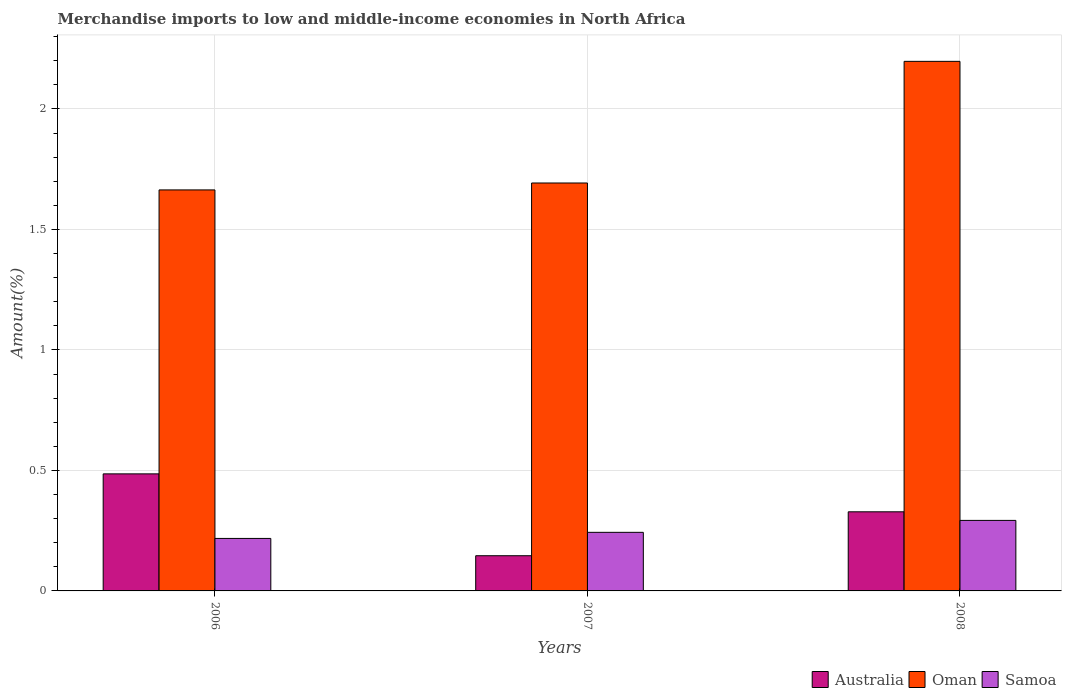Are the number of bars per tick equal to the number of legend labels?
Provide a succinct answer. Yes. How many bars are there on the 1st tick from the right?
Give a very brief answer. 3. In how many cases, is the number of bars for a given year not equal to the number of legend labels?
Your response must be concise. 0. What is the percentage of amount earned from merchandise imports in Samoa in 2007?
Your answer should be compact. 0.24. Across all years, what is the maximum percentage of amount earned from merchandise imports in Samoa?
Your response must be concise. 0.29. Across all years, what is the minimum percentage of amount earned from merchandise imports in Australia?
Ensure brevity in your answer.  0.15. What is the total percentage of amount earned from merchandise imports in Oman in the graph?
Keep it short and to the point. 5.55. What is the difference between the percentage of amount earned from merchandise imports in Samoa in 2007 and that in 2008?
Give a very brief answer. -0.05. What is the difference between the percentage of amount earned from merchandise imports in Oman in 2008 and the percentage of amount earned from merchandise imports in Australia in 2006?
Your response must be concise. 1.71. What is the average percentage of amount earned from merchandise imports in Samoa per year?
Your answer should be compact. 0.25. In the year 2008, what is the difference between the percentage of amount earned from merchandise imports in Australia and percentage of amount earned from merchandise imports in Samoa?
Provide a succinct answer. 0.04. What is the ratio of the percentage of amount earned from merchandise imports in Oman in 2006 to that in 2008?
Make the answer very short. 0.76. What is the difference between the highest and the second highest percentage of amount earned from merchandise imports in Oman?
Ensure brevity in your answer.  0.5. What is the difference between the highest and the lowest percentage of amount earned from merchandise imports in Samoa?
Your answer should be compact. 0.07. What does the 3rd bar from the left in 2008 represents?
Provide a short and direct response. Samoa. What does the 2nd bar from the right in 2008 represents?
Make the answer very short. Oman. Is it the case that in every year, the sum of the percentage of amount earned from merchandise imports in Australia and percentage of amount earned from merchandise imports in Samoa is greater than the percentage of amount earned from merchandise imports in Oman?
Offer a very short reply. No. How many bars are there?
Keep it short and to the point. 9. Are all the bars in the graph horizontal?
Provide a short and direct response. No. Are the values on the major ticks of Y-axis written in scientific E-notation?
Provide a short and direct response. No. Does the graph contain any zero values?
Make the answer very short. No. What is the title of the graph?
Make the answer very short. Merchandise imports to low and middle-income economies in North Africa. What is the label or title of the Y-axis?
Make the answer very short. Amount(%). What is the Amount(%) in Australia in 2006?
Your answer should be compact. 0.49. What is the Amount(%) in Oman in 2006?
Provide a short and direct response. 1.66. What is the Amount(%) in Samoa in 2006?
Give a very brief answer. 0.22. What is the Amount(%) in Australia in 2007?
Give a very brief answer. 0.15. What is the Amount(%) in Oman in 2007?
Your response must be concise. 1.69. What is the Amount(%) in Samoa in 2007?
Your response must be concise. 0.24. What is the Amount(%) in Australia in 2008?
Ensure brevity in your answer.  0.33. What is the Amount(%) in Oman in 2008?
Make the answer very short. 2.2. What is the Amount(%) of Samoa in 2008?
Offer a very short reply. 0.29. Across all years, what is the maximum Amount(%) in Australia?
Make the answer very short. 0.49. Across all years, what is the maximum Amount(%) of Oman?
Provide a succinct answer. 2.2. Across all years, what is the maximum Amount(%) in Samoa?
Provide a short and direct response. 0.29. Across all years, what is the minimum Amount(%) in Australia?
Provide a short and direct response. 0.15. Across all years, what is the minimum Amount(%) in Oman?
Your answer should be very brief. 1.66. Across all years, what is the minimum Amount(%) of Samoa?
Offer a very short reply. 0.22. What is the total Amount(%) of Australia in the graph?
Provide a short and direct response. 0.96. What is the total Amount(%) of Oman in the graph?
Your answer should be very brief. 5.55. What is the total Amount(%) of Samoa in the graph?
Provide a short and direct response. 0.75. What is the difference between the Amount(%) of Australia in 2006 and that in 2007?
Make the answer very short. 0.34. What is the difference between the Amount(%) in Oman in 2006 and that in 2007?
Your response must be concise. -0.03. What is the difference between the Amount(%) of Samoa in 2006 and that in 2007?
Ensure brevity in your answer.  -0.03. What is the difference between the Amount(%) of Australia in 2006 and that in 2008?
Your response must be concise. 0.16. What is the difference between the Amount(%) of Oman in 2006 and that in 2008?
Offer a very short reply. -0.53. What is the difference between the Amount(%) of Samoa in 2006 and that in 2008?
Ensure brevity in your answer.  -0.07. What is the difference between the Amount(%) of Australia in 2007 and that in 2008?
Your answer should be compact. -0.18. What is the difference between the Amount(%) in Oman in 2007 and that in 2008?
Your answer should be very brief. -0.5. What is the difference between the Amount(%) in Samoa in 2007 and that in 2008?
Make the answer very short. -0.05. What is the difference between the Amount(%) of Australia in 2006 and the Amount(%) of Oman in 2007?
Ensure brevity in your answer.  -1.21. What is the difference between the Amount(%) of Australia in 2006 and the Amount(%) of Samoa in 2007?
Offer a terse response. 0.24. What is the difference between the Amount(%) in Oman in 2006 and the Amount(%) in Samoa in 2007?
Offer a terse response. 1.42. What is the difference between the Amount(%) of Australia in 2006 and the Amount(%) of Oman in 2008?
Provide a short and direct response. -1.71. What is the difference between the Amount(%) of Australia in 2006 and the Amount(%) of Samoa in 2008?
Your answer should be very brief. 0.19. What is the difference between the Amount(%) in Oman in 2006 and the Amount(%) in Samoa in 2008?
Offer a terse response. 1.37. What is the difference between the Amount(%) in Australia in 2007 and the Amount(%) in Oman in 2008?
Provide a succinct answer. -2.05. What is the difference between the Amount(%) of Australia in 2007 and the Amount(%) of Samoa in 2008?
Ensure brevity in your answer.  -0.15. What is the average Amount(%) of Australia per year?
Offer a very short reply. 0.32. What is the average Amount(%) in Oman per year?
Provide a succinct answer. 1.85. What is the average Amount(%) of Samoa per year?
Ensure brevity in your answer.  0.25. In the year 2006, what is the difference between the Amount(%) in Australia and Amount(%) in Oman?
Provide a succinct answer. -1.18. In the year 2006, what is the difference between the Amount(%) in Australia and Amount(%) in Samoa?
Give a very brief answer. 0.27. In the year 2006, what is the difference between the Amount(%) in Oman and Amount(%) in Samoa?
Provide a succinct answer. 1.45. In the year 2007, what is the difference between the Amount(%) of Australia and Amount(%) of Oman?
Make the answer very short. -1.55. In the year 2007, what is the difference between the Amount(%) in Australia and Amount(%) in Samoa?
Ensure brevity in your answer.  -0.1. In the year 2007, what is the difference between the Amount(%) in Oman and Amount(%) in Samoa?
Keep it short and to the point. 1.45. In the year 2008, what is the difference between the Amount(%) in Australia and Amount(%) in Oman?
Make the answer very short. -1.87. In the year 2008, what is the difference between the Amount(%) in Australia and Amount(%) in Samoa?
Ensure brevity in your answer.  0.04. In the year 2008, what is the difference between the Amount(%) of Oman and Amount(%) of Samoa?
Keep it short and to the point. 1.9. What is the ratio of the Amount(%) in Australia in 2006 to that in 2007?
Your response must be concise. 3.33. What is the ratio of the Amount(%) of Samoa in 2006 to that in 2007?
Ensure brevity in your answer.  0.9. What is the ratio of the Amount(%) in Australia in 2006 to that in 2008?
Your response must be concise. 1.48. What is the ratio of the Amount(%) in Oman in 2006 to that in 2008?
Make the answer very short. 0.76. What is the ratio of the Amount(%) of Samoa in 2006 to that in 2008?
Give a very brief answer. 0.74. What is the ratio of the Amount(%) in Australia in 2007 to that in 2008?
Ensure brevity in your answer.  0.44. What is the ratio of the Amount(%) of Oman in 2007 to that in 2008?
Keep it short and to the point. 0.77. What is the ratio of the Amount(%) of Samoa in 2007 to that in 2008?
Provide a short and direct response. 0.83. What is the difference between the highest and the second highest Amount(%) in Australia?
Provide a succinct answer. 0.16. What is the difference between the highest and the second highest Amount(%) in Oman?
Offer a very short reply. 0.5. What is the difference between the highest and the second highest Amount(%) in Samoa?
Your answer should be very brief. 0.05. What is the difference between the highest and the lowest Amount(%) of Australia?
Give a very brief answer. 0.34. What is the difference between the highest and the lowest Amount(%) of Oman?
Make the answer very short. 0.53. What is the difference between the highest and the lowest Amount(%) of Samoa?
Give a very brief answer. 0.07. 